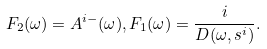Convert formula to latex. <formula><loc_0><loc_0><loc_500><loc_500>F _ { 2 } ( \omega ) = A ^ { i - } ( \omega ) , F _ { 1 } ( \omega ) = \frac { i } { D ( \omega , s ^ { i } ) } .</formula> 